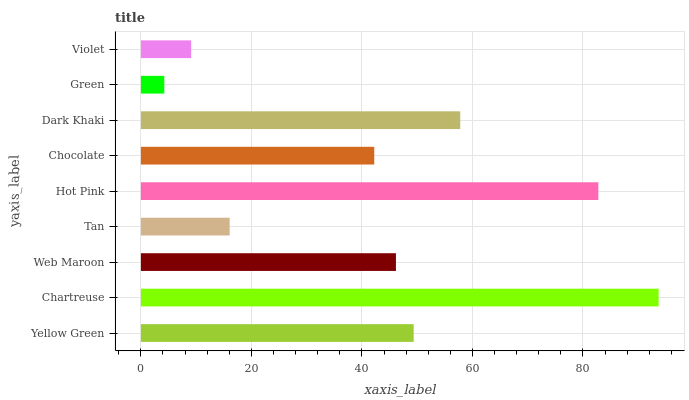Is Green the minimum?
Answer yes or no. Yes. Is Chartreuse the maximum?
Answer yes or no. Yes. Is Web Maroon the minimum?
Answer yes or no. No. Is Web Maroon the maximum?
Answer yes or no. No. Is Chartreuse greater than Web Maroon?
Answer yes or no. Yes. Is Web Maroon less than Chartreuse?
Answer yes or no. Yes. Is Web Maroon greater than Chartreuse?
Answer yes or no. No. Is Chartreuse less than Web Maroon?
Answer yes or no. No. Is Web Maroon the high median?
Answer yes or no. Yes. Is Web Maroon the low median?
Answer yes or no. Yes. Is Dark Khaki the high median?
Answer yes or no. No. Is Hot Pink the low median?
Answer yes or no. No. 